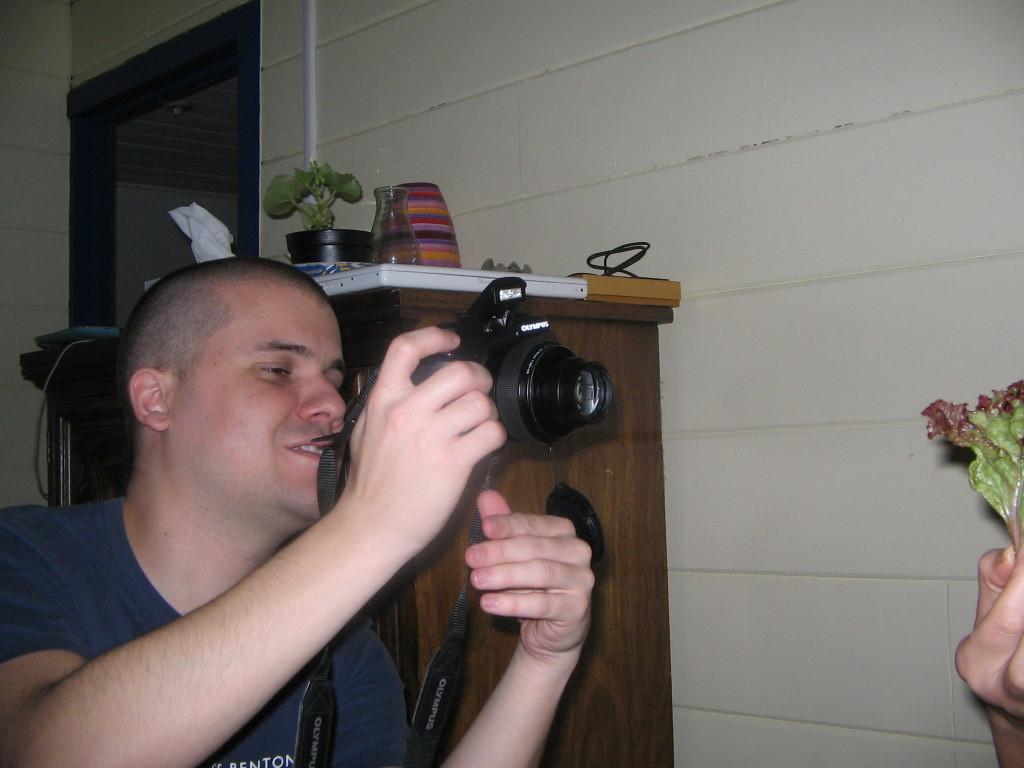What is the man in the image holding? The man is holding a camera in the image. What other objects can be seen in the image besides the camera? There is a flask, a bowl, a plant, and a tray on the table in the image. What is the background of the image? There is a wall in the image. What type of operation is the man performing on the moon in the image? There is no moon or operation present in the image; it features a man holding a camera, a flask, a bowl, a plant, and a tray on a table in front of a wall. 